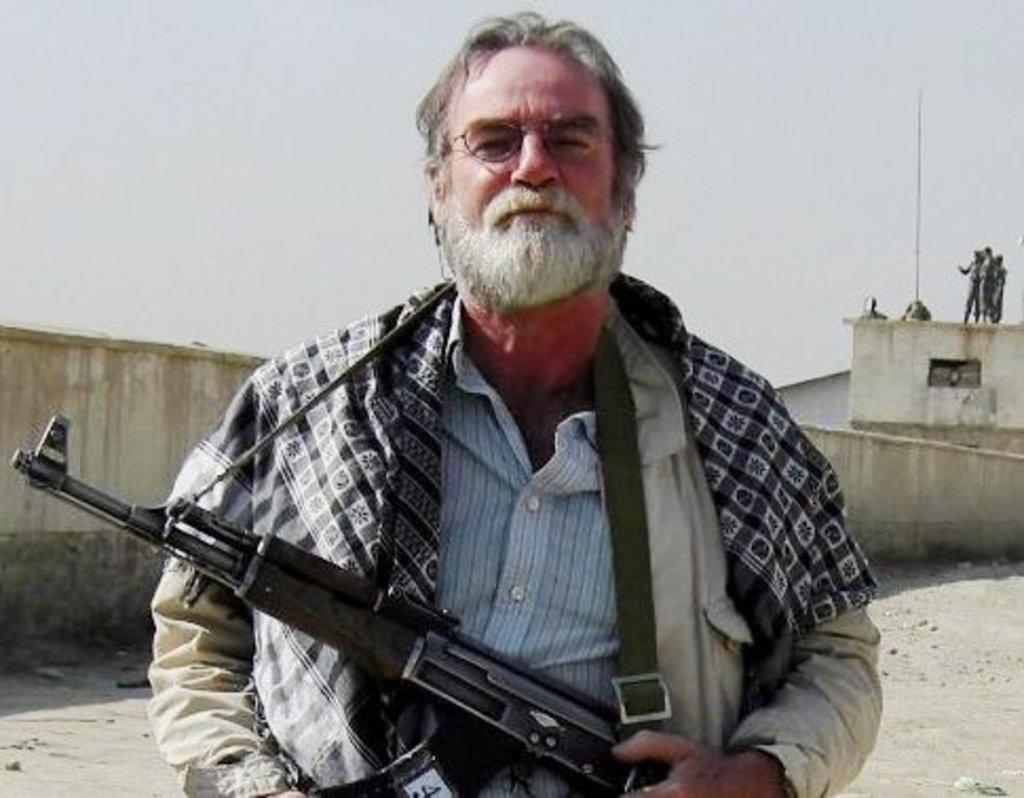What is the person in the image wearing? The person is wearing spectacles in the image. What is the person holding in the image? The person is holding a gun in the image. Can you describe the setting of the image? There are other people on the roof and a wall is visible in the image. What type of box is being used to store the forks in the image? There is no box or forks present in the image. Can you describe the airplane in the image? There is no airplane present in the image. 